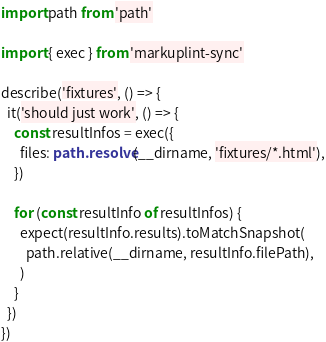<code> <loc_0><loc_0><loc_500><loc_500><_TypeScript_>import path from 'path'

import { exec } from 'markuplint-sync'

describe('fixtures', () => {
  it('should just work', () => {
    const resultInfos = exec({
      files: path.resolve(__dirname, 'fixtures/*.html'),
    })

    for (const resultInfo of resultInfos) {
      expect(resultInfo.results).toMatchSnapshot(
        path.relative(__dirname, resultInfo.filePath),
      )
    }
  })
})
</code> 